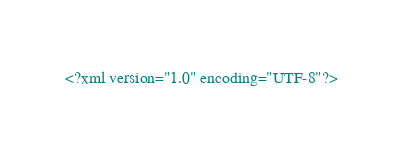<code> <loc_0><loc_0><loc_500><loc_500><_XML_><?xml version="1.0" encoding="UTF-8"?></code> 